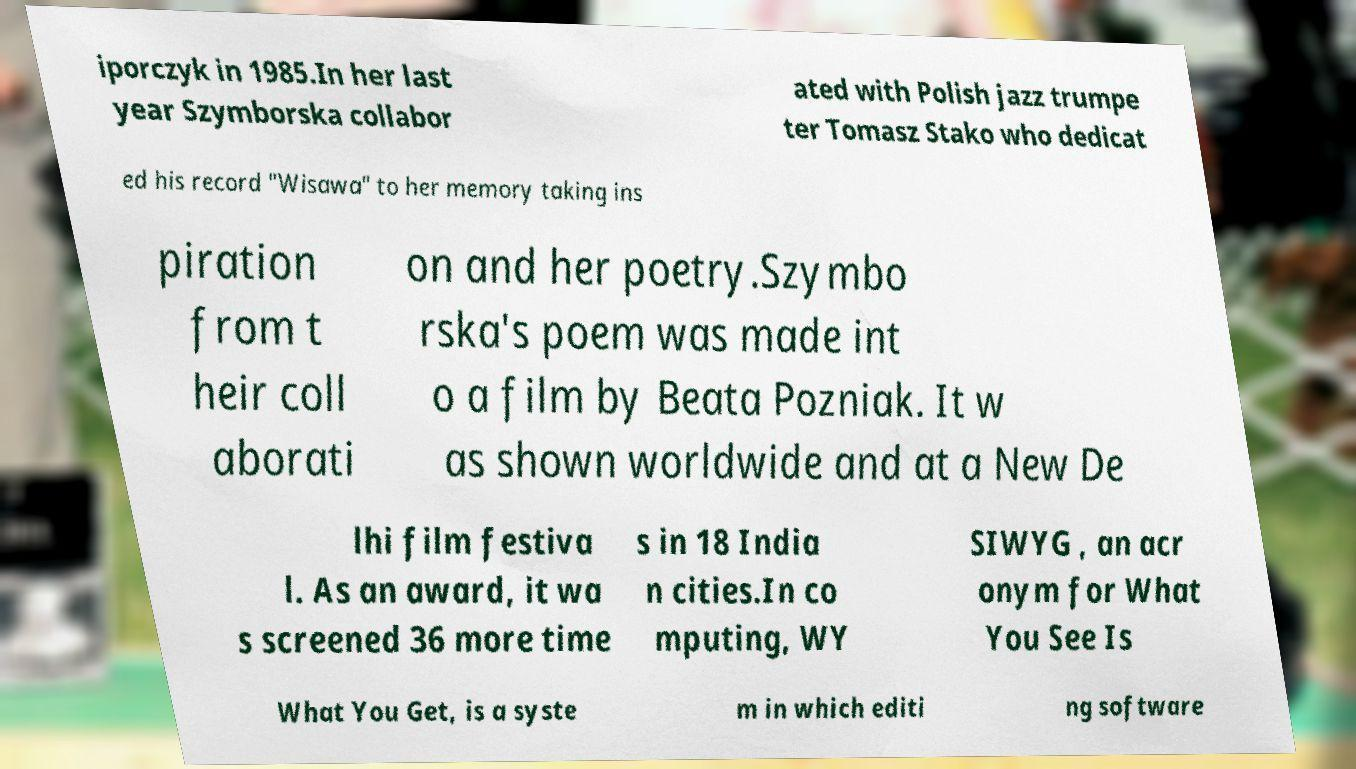Could you extract and type out the text from this image? iporczyk in 1985.In her last year Szymborska collabor ated with Polish jazz trumpe ter Tomasz Stako who dedicat ed his record "Wisawa" to her memory taking ins piration from t heir coll aborati on and her poetry.Szymbo rska's poem was made int o a film by Beata Pozniak. It w as shown worldwide and at a New De lhi film festiva l. As an award, it wa s screened 36 more time s in 18 India n cities.In co mputing, WY SIWYG , an acr onym for What You See Is What You Get, is a syste m in which editi ng software 